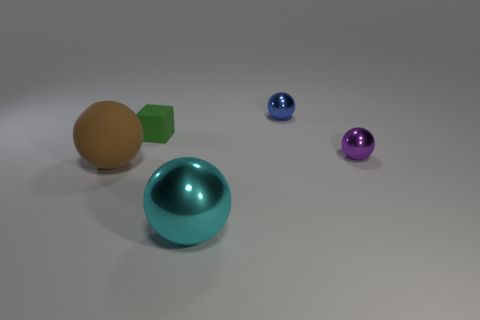Add 5 tiny shiny things. How many objects exist? 10 Subtract all blocks. How many objects are left? 4 Add 5 purple metallic things. How many purple metallic things are left? 6 Add 3 purple shiny objects. How many purple shiny objects exist? 4 Subtract 0 brown blocks. How many objects are left? 5 Subtract all tiny brown metal spheres. Subtract all big cyan objects. How many objects are left? 4 